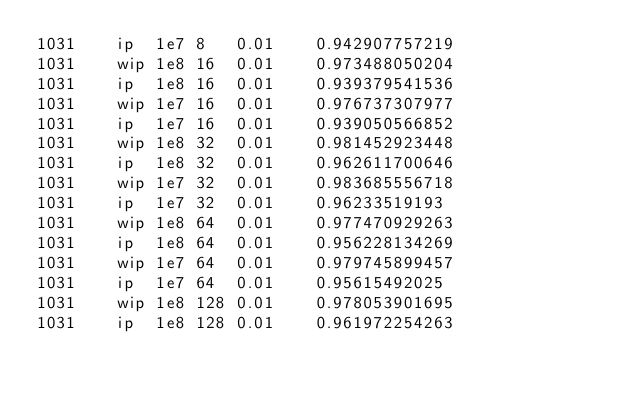<code> <loc_0><loc_0><loc_500><loc_500><_SQL_>1031	ip	1e7	8	0.01	0.942907757219
1031	wip	1e8	16	0.01	0.973488050204
1031	ip	1e8	16	0.01	0.939379541536
1031	wip	1e7	16	0.01	0.976737307977
1031	ip	1e7	16	0.01	0.939050566852
1031	wip	1e8	32	0.01	0.981452923448
1031	ip	1e8	32	0.01	0.962611700646
1031	wip	1e7	32	0.01	0.983685556718
1031	ip	1e7	32	0.01	0.96233519193
1031	wip	1e8	64	0.01	0.977470929263
1031	ip	1e8	64	0.01	0.956228134269
1031	wip	1e7	64	0.01	0.979745899457
1031	ip	1e7	64	0.01	0.95615492025
1031	wip	1e8	128	0.01	0.978053901695
1031	ip	1e8	128	0.01	0.961972254263</code> 